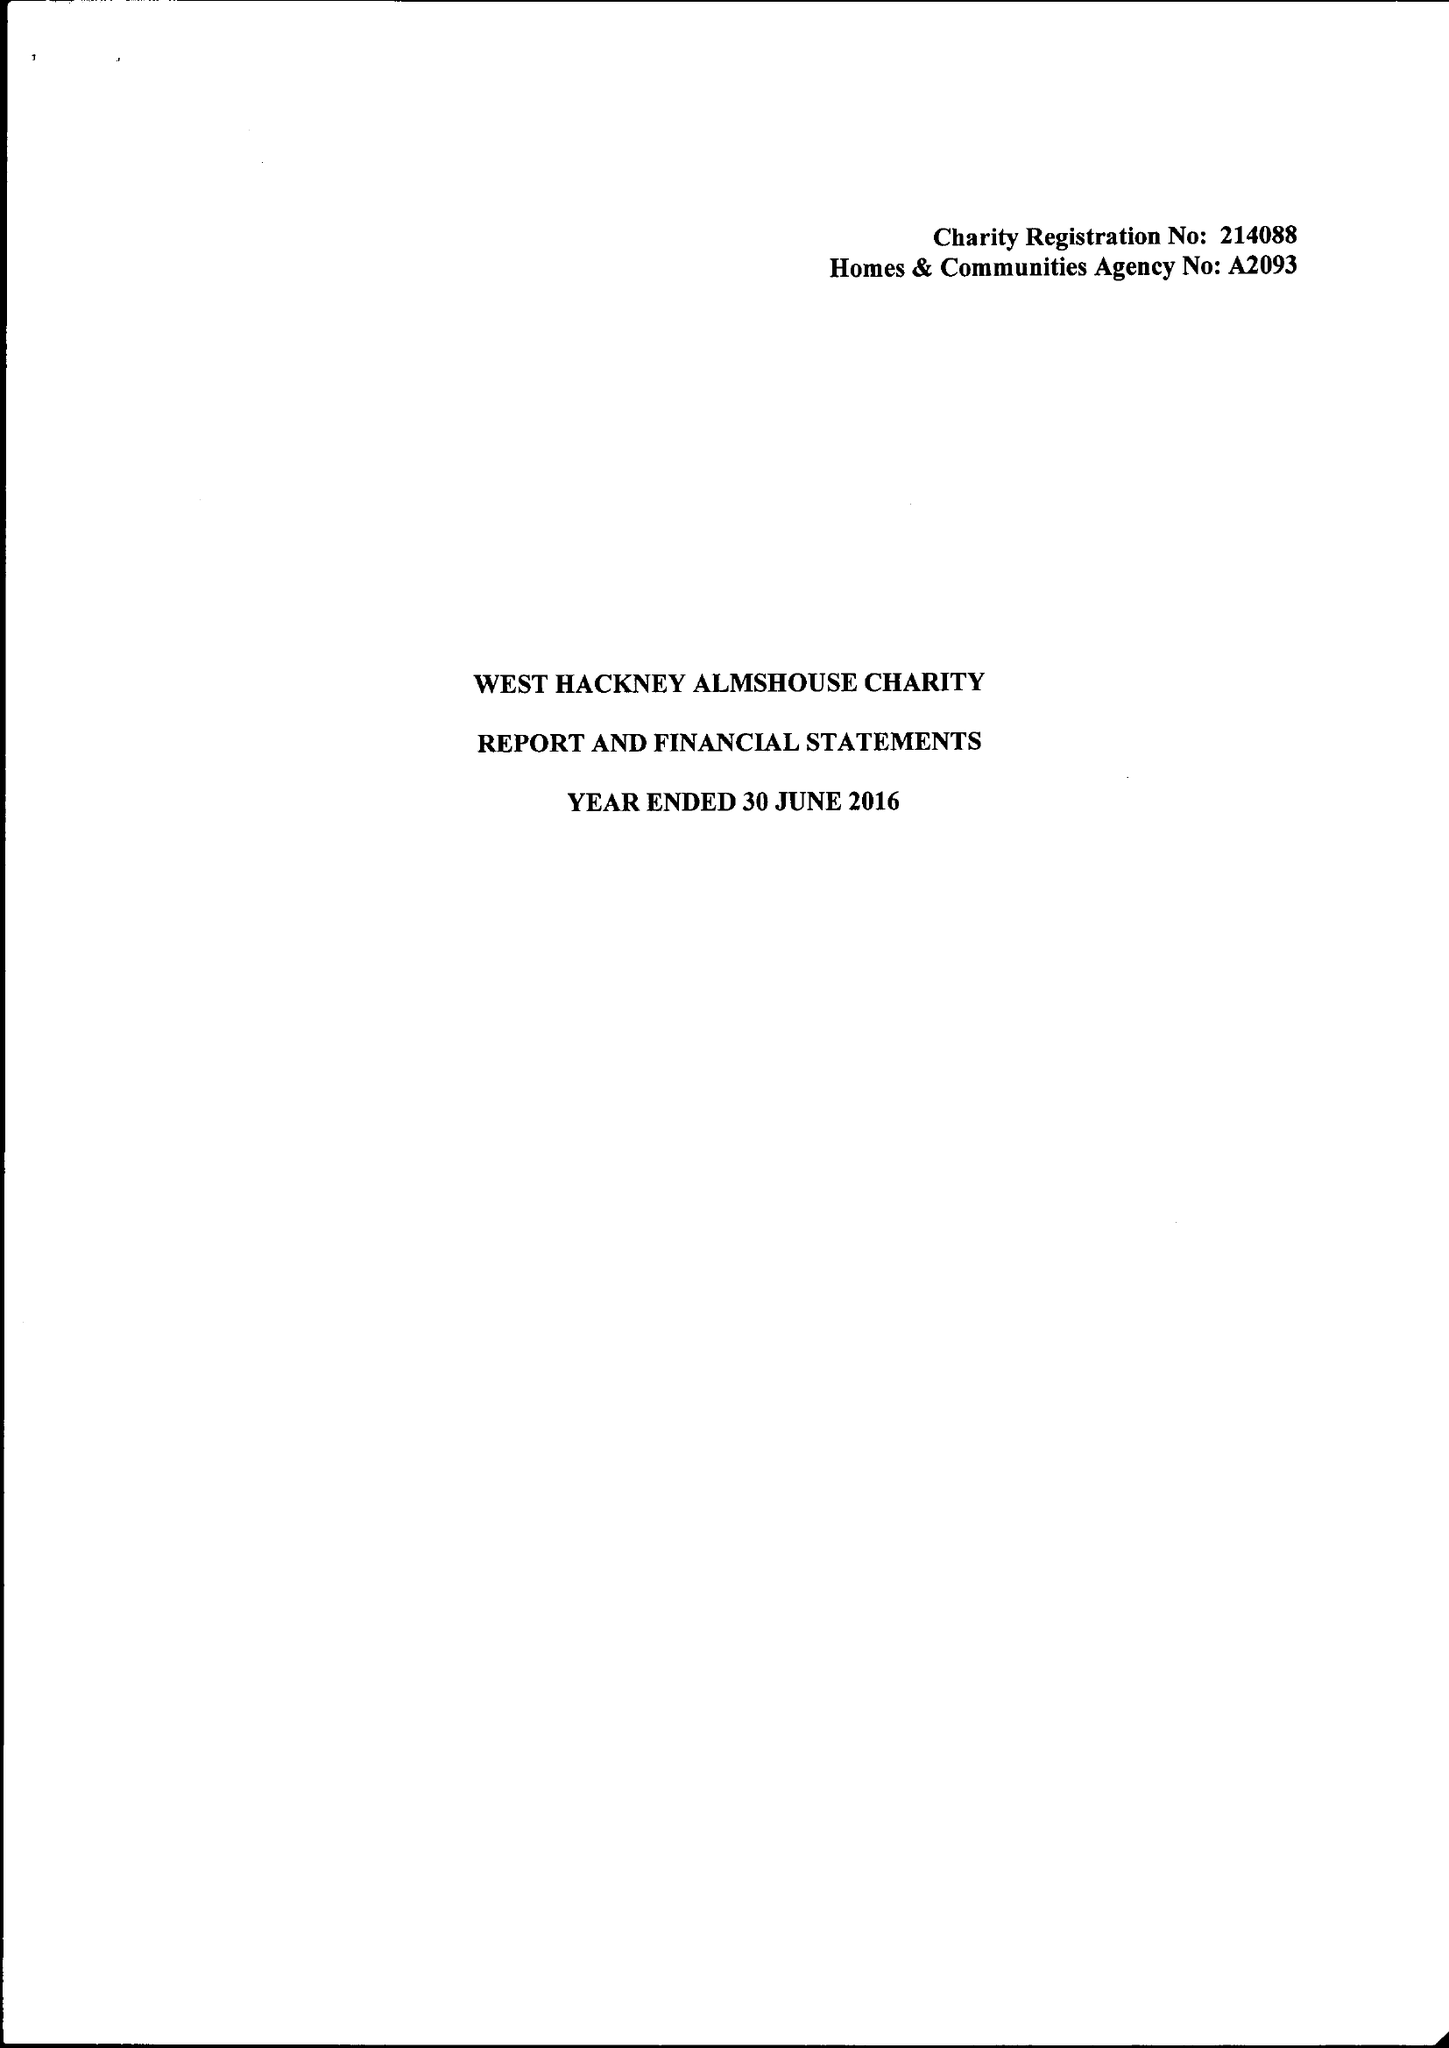What is the value for the address__postcode?
Answer the question using a single word or phrase. W11 4RQ 